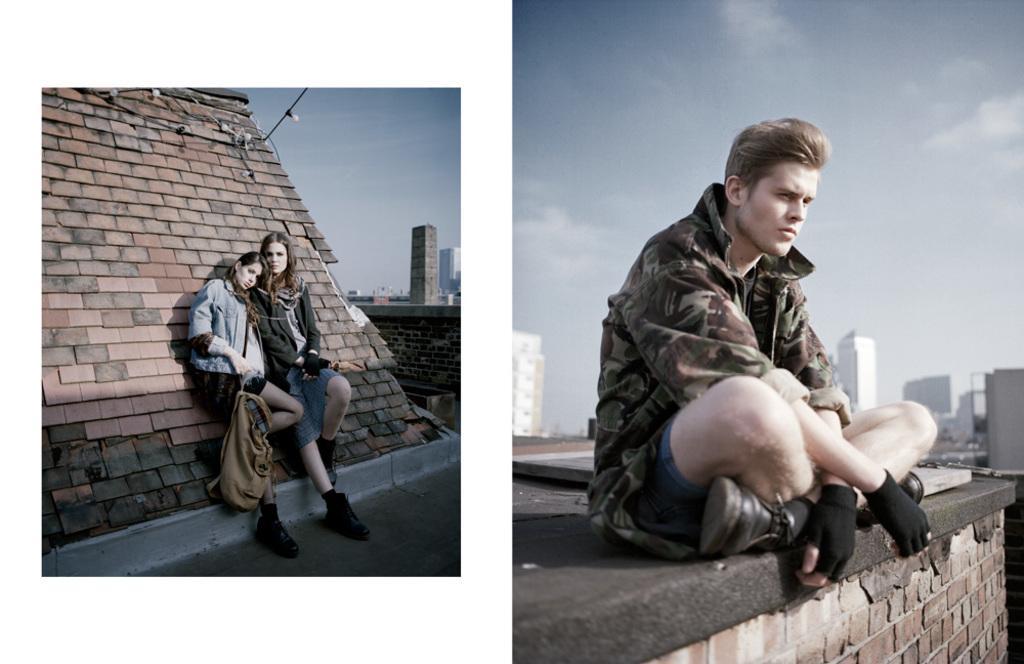In one or two sentences, can you explain what this image depicts? This picture shows a college and we see couple of women standing and we see a woman holding a bag in her hand and we see a brick wall and we see buildings in the second image we see a man seated and we see buildings and a blue cloudy Sky. 